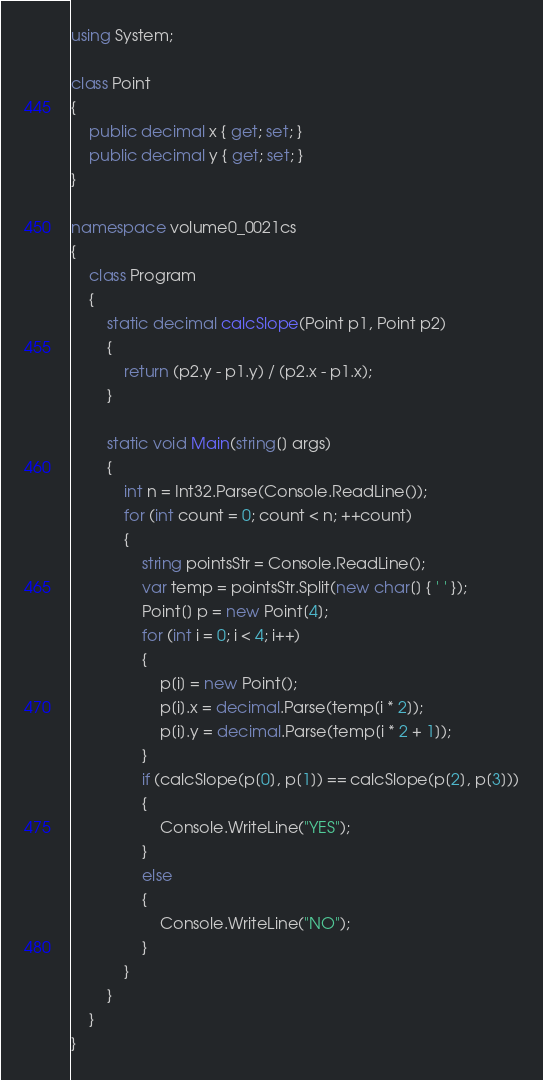<code> <loc_0><loc_0><loc_500><loc_500><_C#_>using System;

class Point
{
    public decimal x { get; set; }
    public decimal y { get; set; }
}

namespace volume0_0021cs
{
    class Program
    {
        static decimal calcSlope(Point p1, Point p2)
        {
            return (p2.y - p1.y) / (p2.x - p1.x);
        }

        static void Main(string[] args)
        {
            int n = Int32.Parse(Console.ReadLine());
            for (int count = 0; count < n; ++count)
            {
                string pointsStr = Console.ReadLine();
                var temp = pointsStr.Split(new char[] { ' ' });
                Point[] p = new Point[4];
                for (int i = 0; i < 4; i++)
                {
                    p[i] = new Point();
                    p[i].x = decimal.Parse(temp[i * 2]);
                    p[i].y = decimal.Parse(temp[i * 2 + 1]);
                }
                if (calcSlope(p[0], p[1]) == calcSlope(p[2], p[3]))
                {
                    Console.WriteLine("YES");
                }
                else
                {
                    Console.WriteLine("NO");
                }
            }
        }
    }
}</code> 